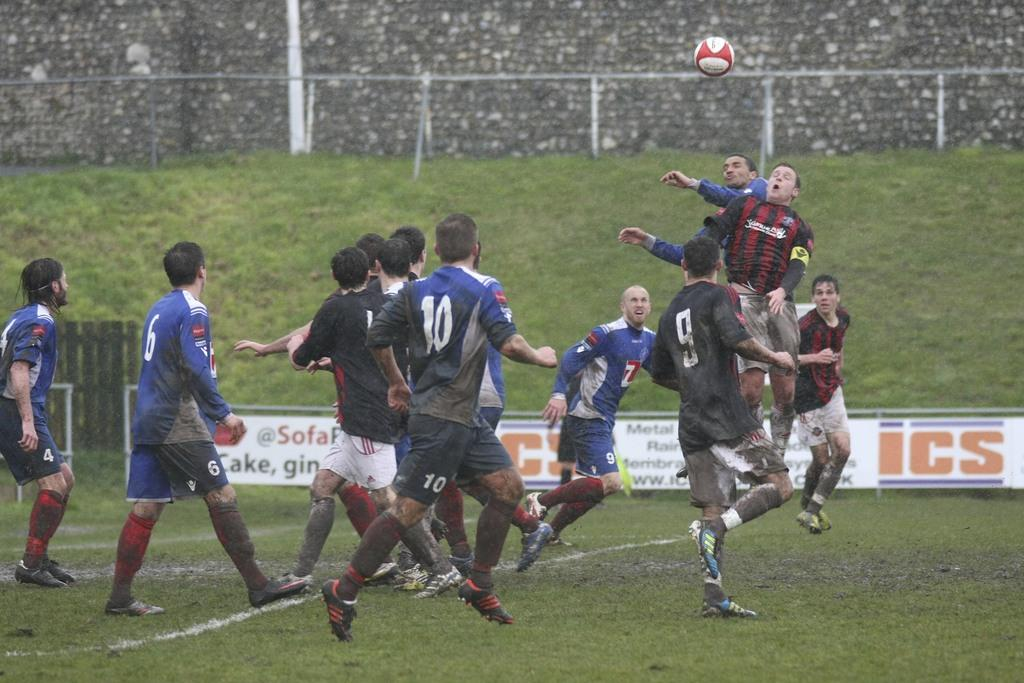Provide a one-sentence caption for the provided image. A banner that has the letters ICS on it. 